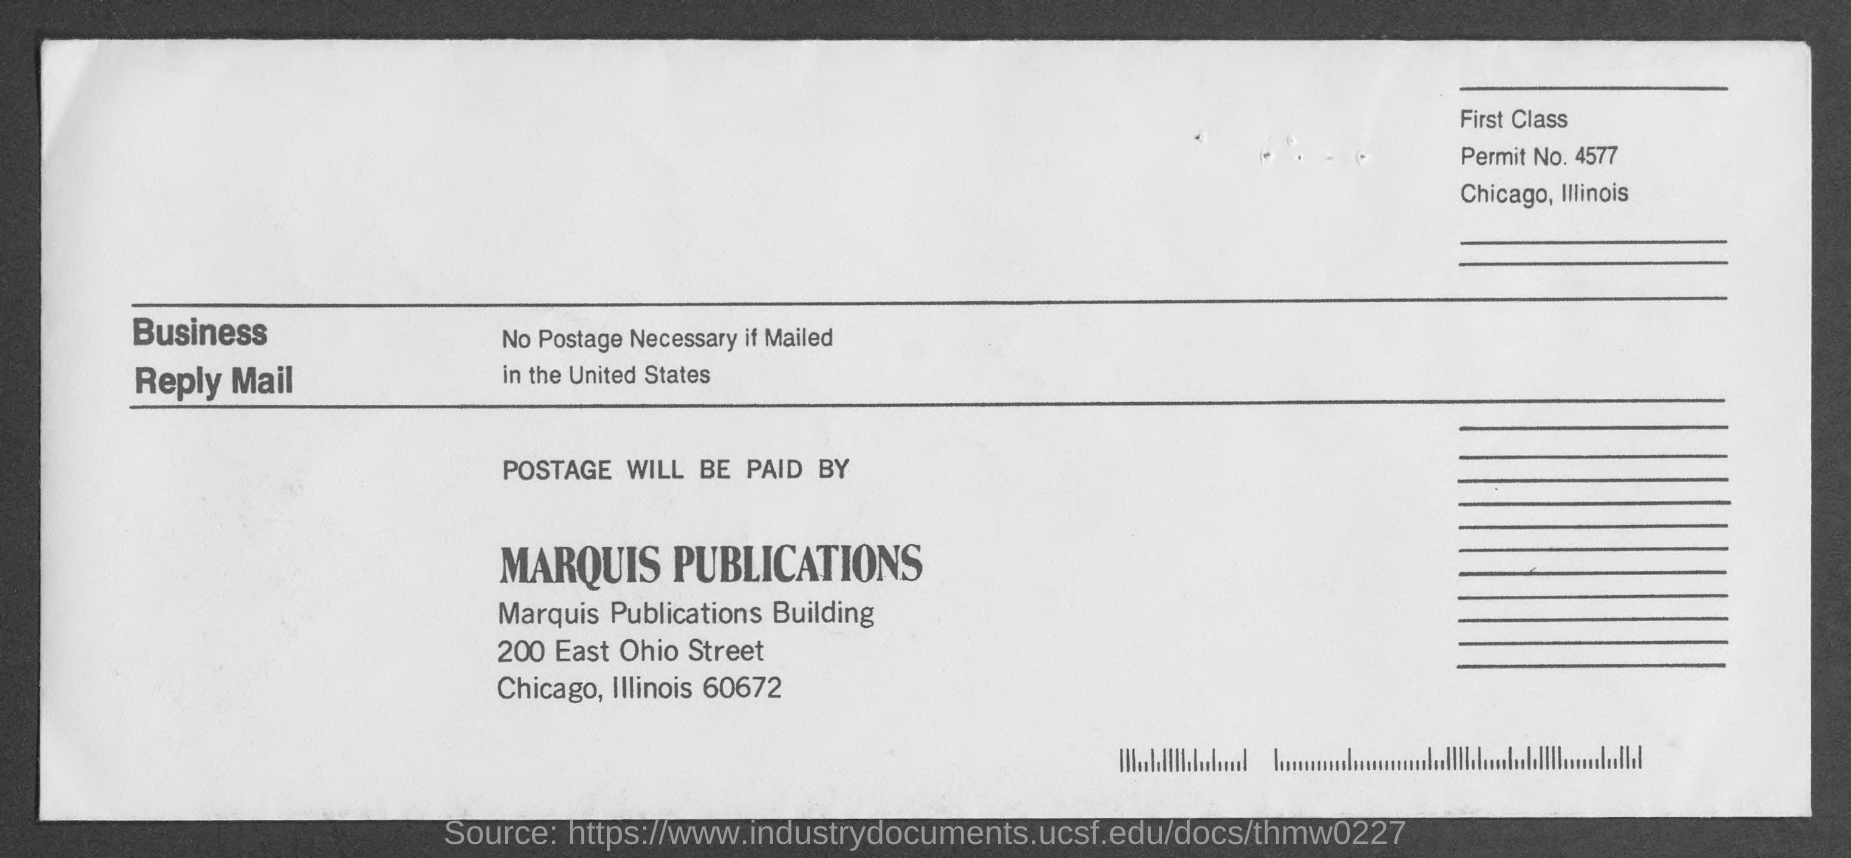Draw attention to some important aspects in this diagram. The postage will be paid by Marquis Publications. The given email mentions a permit number of 4577. 